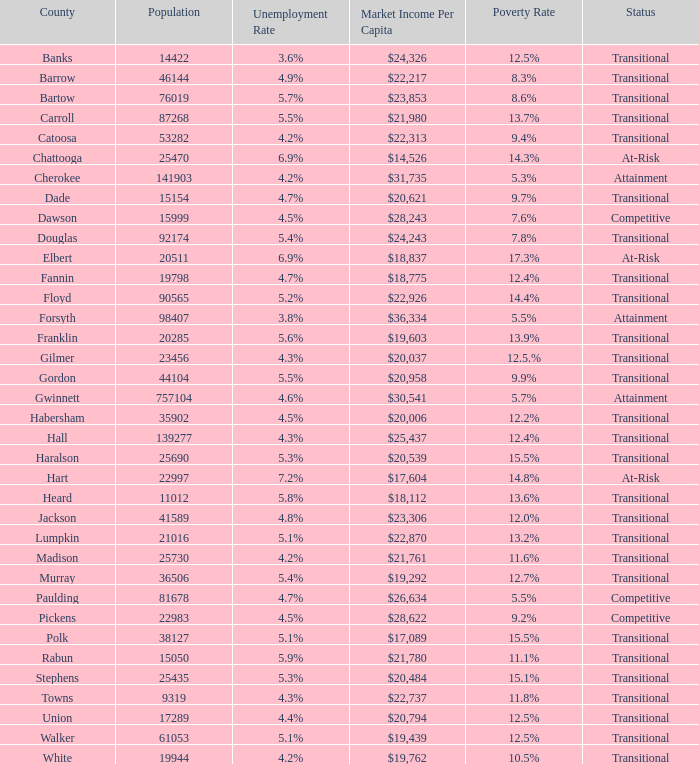What is the status of the county with per capita market income of $24,326? Transitional. Could you parse the entire table? {'header': ['County', 'Population', 'Unemployment Rate', 'Market Income Per Capita', 'Poverty Rate', 'Status'], 'rows': [['Banks', '14422', '3.6%', '$24,326', '12.5%', 'Transitional'], ['Barrow', '46144', '4.9%', '$22,217', '8.3%', 'Transitional'], ['Bartow', '76019', '5.7%', '$23,853', '8.6%', 'Transitional'], ['Carroll', '87268', '5.5%', '$21,980', '13.7%', 'Transitional'], ['Catoosa', '53282', '4.2%', '$22,313', '9.4%', 'Transitional'], ['Chattooga', '25470', '6.9%', '$14,526', '14.3%', 'At-Risk'], ['Cherokee', '141903', '4.2%', '$31,735', '5.3%', 'Attainment'], ['Dade', '15154', '4.7%', '$20,621', '9.7%', 'Transitional'], ['Dawson', '15999', '4.5%', '$28,243', '7.6%', 'Competitive'], ['Douglas', '92174', '5.4%', '$24,243', '7.8%', 'Transitional'], ['Elbert', '20511', '6.9%', '$18,837', '17.3%', 'At-Risk'], ['Fannin', '19798', '4.7%', '$18,775', '12.4%', 'Transitional'], ['Floyd', '90565', '5.2%', '$22,926', '14.4%', 'Transitional'], ['Forsyth', '98407', '3.8%', '$36,334', '5.5%', 'Attainment'], ['Franklin', '20285', '5.6%', '$19,603', '13.9%', 'Transitional'], ['Gilmer', '23456', '4.3%', '$20,037', '12.5.%', 'Transitional'], ['Gordon', '44104', '5.5%', '$20,958', '9.9%', 'Transitional'], ['Gwinnett', '757104', '4.6%', '$30,541', '5.7%', 'Attainment'], ['Habersham', '35902', '4.5%', '$20,006', '12.2%', 'Transitional'], ['Hall', '139277', '4.3%', '$25,437', '12.4%', 'Transitional'], ['Haralson', '25690', '5.3%', '$20,539', '15.5%', 'Transitional'], ['Hart', '22997', '7.2%', '$17,604', '14.8%', 'At-Risk'], ['Heard', '11012', '5.8%', '$18,112', '13.6%', 'Transitional'], ['Jackson', '41589', '4.8%', '$23,306', '12.0%', 'Transitional'], ['Lumpkin', '21016', '5.1%', '$22,870', '13.2%', 'Transitional'], ['Madison', '25730', '4.2%', '$21,761', '11.6%', 'Transitional'], ['Murray', '36506', '5.4%', '$19,292', '12.7%', 'Transitional'], ['Paulding', '81678', '4.7%', '$26,634', '5.5%', 'Competitive'], ['Pickens', '22983', '4.5%', '$28,622', '9.2%', 'Competitive'], ['Polk', '38127', '5.1%', '$17,089', '15.5%', 'Transitional'], ['Rabun', '15050', '5.9%', '$21,780', '11.1%', 'Transitional'], ['Stephens', '25435', '5.3%', '$20,484', '15.1%', 'Transitional'], ['Towns', '9319', '4.3%', '$22,737', '11.8%', 'Transitional'], ['Union', '17289', '4.4%', '$20,794', '12.5%', 'Transitional'], ['Walker', '61053', '5.1%', '$19,439', '12.5%', 'Transitional'], ['White', '19944', '4.2%', '$19,762', '10.5%', 'Transitional']]} 